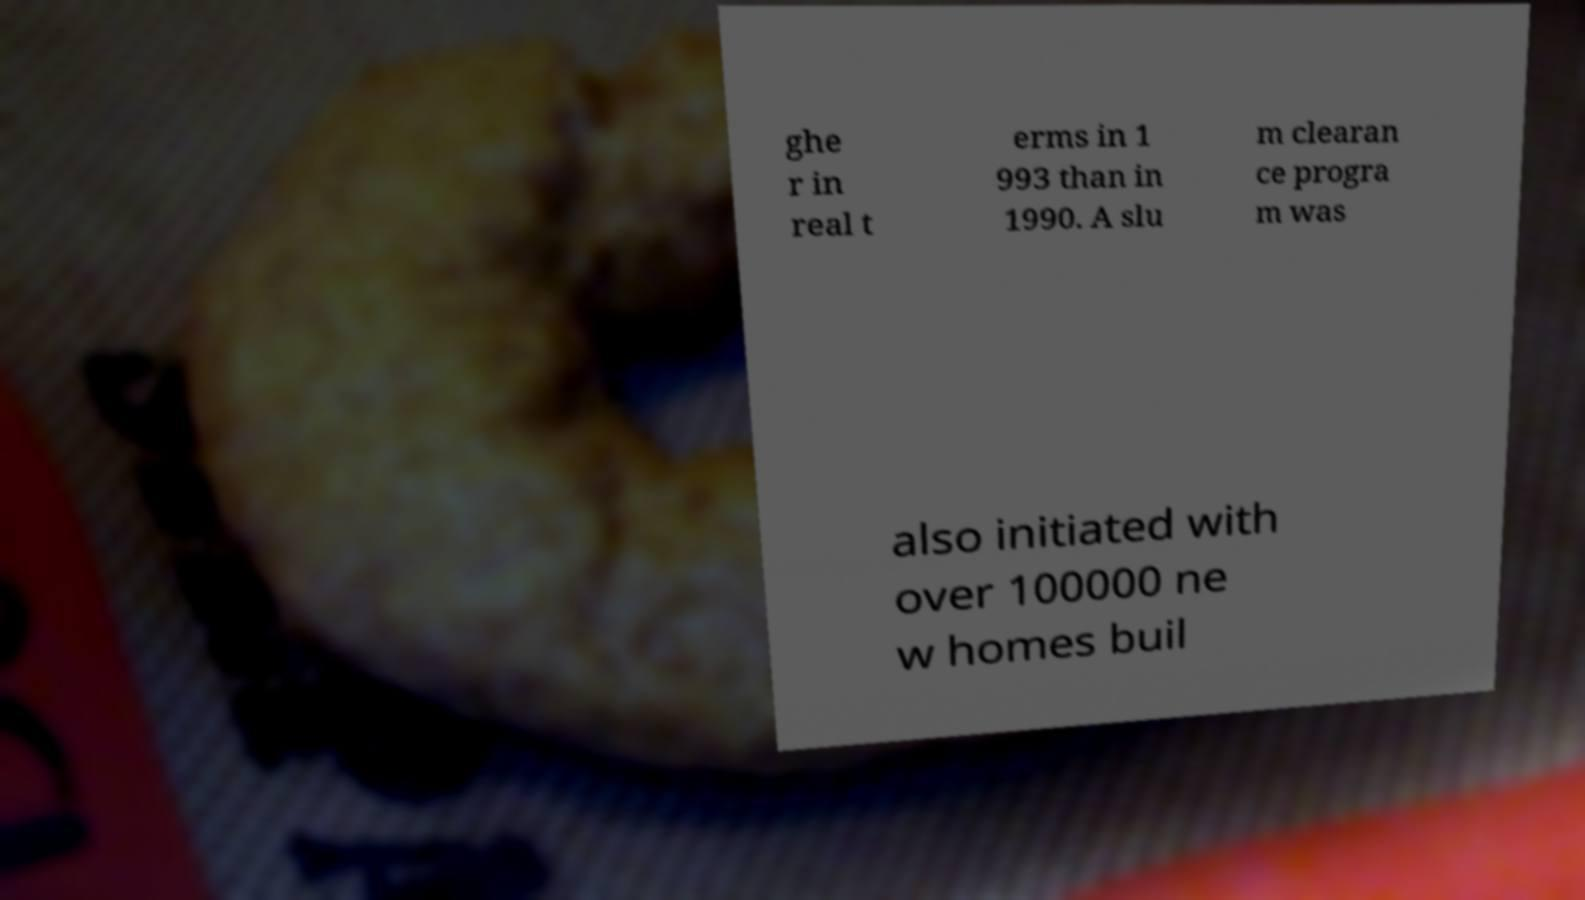I need the written content from this picture converted into text. Can you do that? ghe r in real t erms in 1 993 than in 1990. A slu m clearan ce progra m was also initiated with over 100000 ne w homes buil 